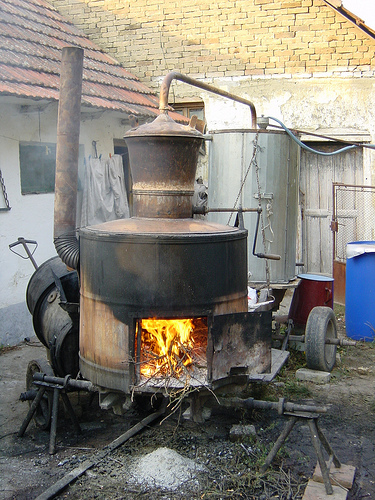<image>
Can you confirm if the fire is in front of the oven? No. The fire is not in front of the oven. The spatial positioning shows a different relationship between these objects. 